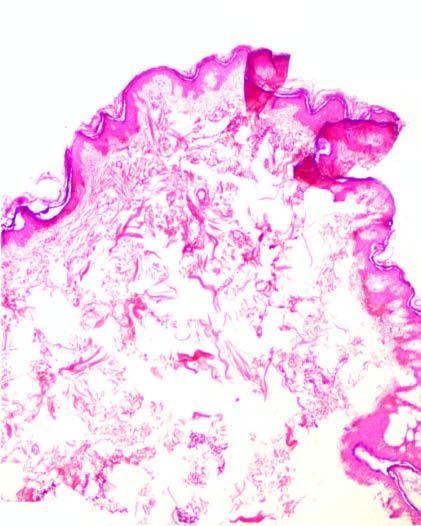what is the epidermis raised as?
Answer the question using a single word or phrase. While some are yellowish-white lesions above surface 